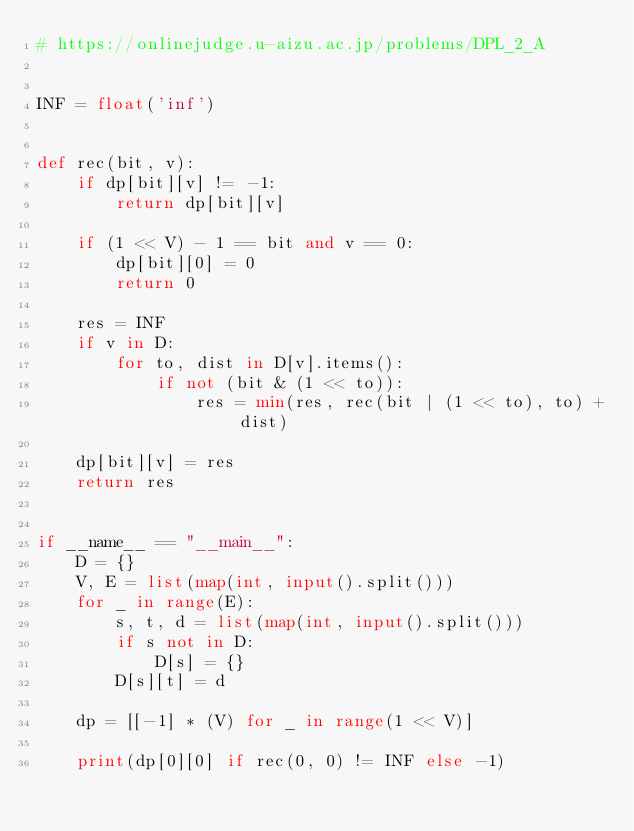<code> <loc_0><loc_0><loc_500><loc_500><_Python_># https://onlinejudge.u-aizu.ac.jp/problems/DPL_2_A


INF = float('inf')


def rec(bit, v):
    if dp[bit][v] != -1:
        return dp[bit][v]

    if (1 << V) - 1 == bit and v == 0:
        dp[bit][0] = 0
        return 0

    res = INF
    if v in D:
        for to, dist in D[v].items():
            if not (bit & (1 << to)):
                res = min(res, rec(bit | (1 << to), to) + dist)

    dp[bit][v] = res
    return res


if __name__ == "__main__":
    D = {}
    V, E = list(map(int, input().split()))
    for _ in range(E):
        s, t, d = list(map(int, input().split()))
        if s not in D:
            D[s] = {}
        D[s][t] = d

    dp = [[-1] * (V) for _ in range(1 << V)]

    print(dp[0][0] if rec(0, 0) != INF else -1)

</code> 